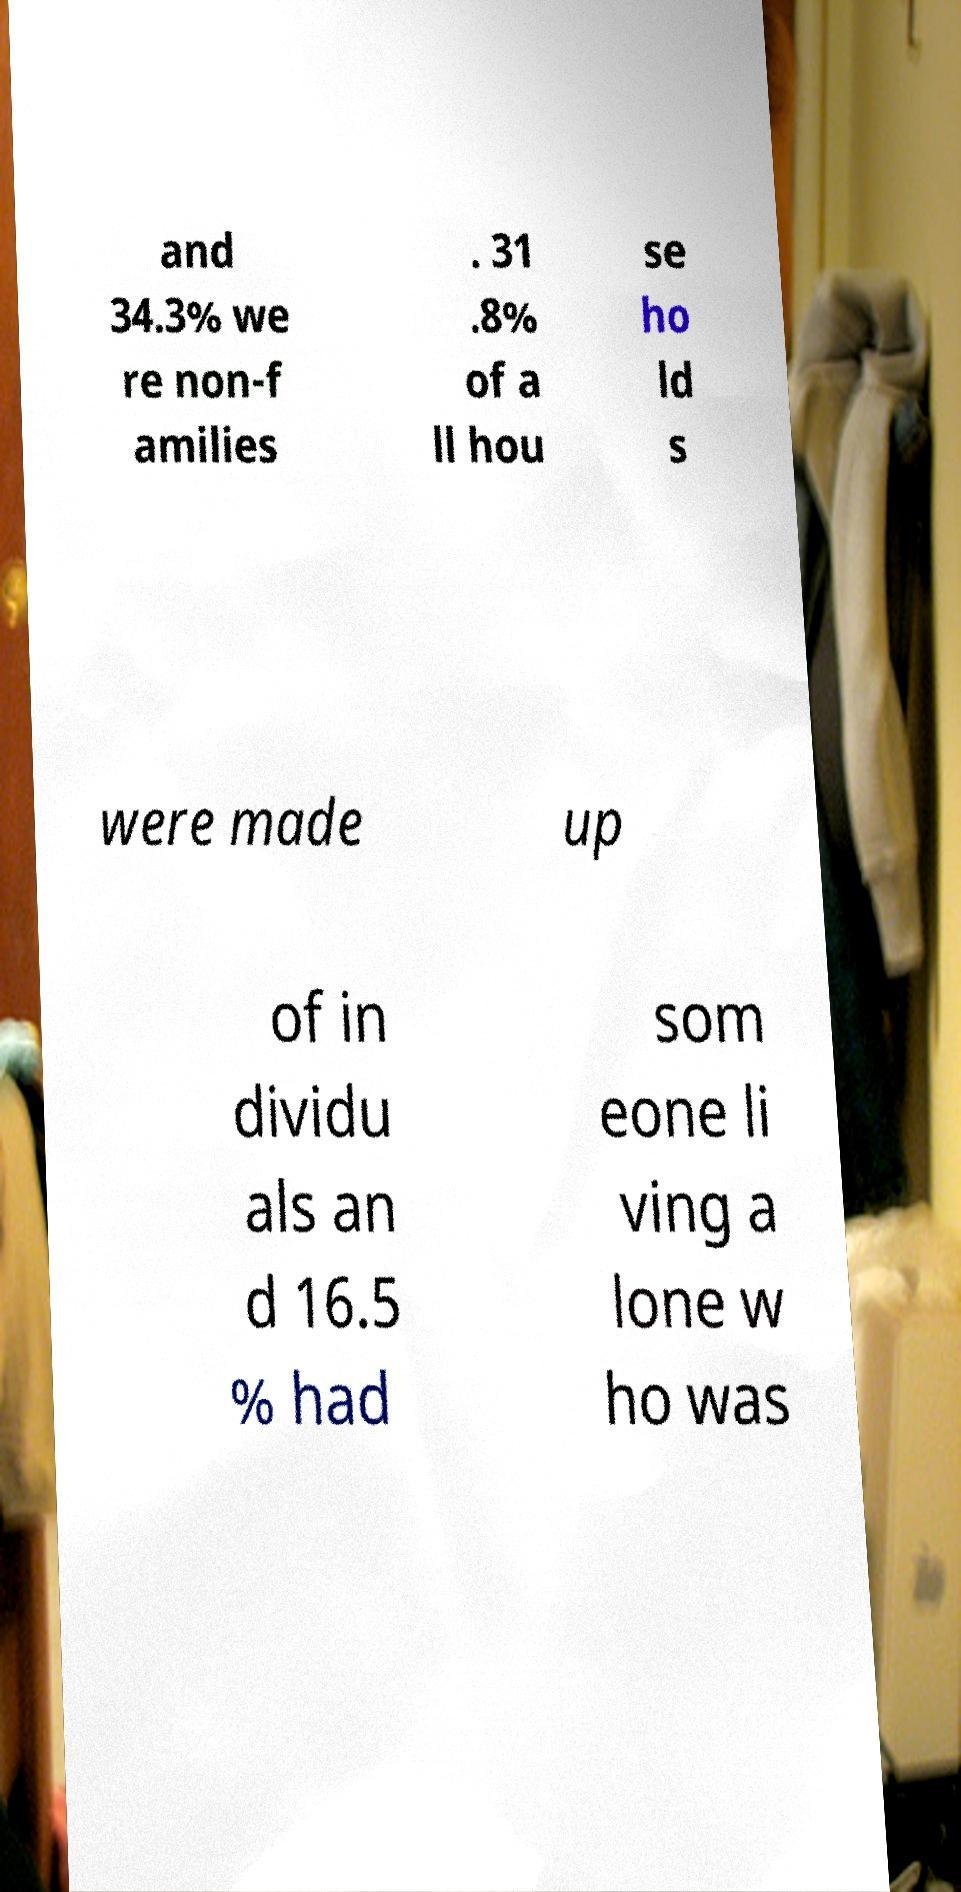For documentation purposes, I need the text within this image transcribed. Could you provide that? and 34.3% we re non-f amilies . 31 .8% of a ll hou se ho ld s were made up of in dividu als an d 16.5 % had som eone li ving a lone w ho was 